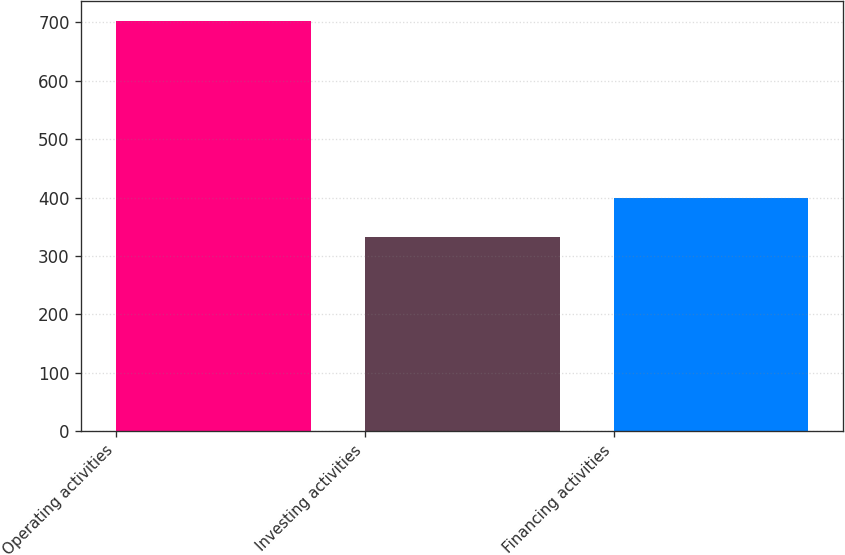Convert chart to OTSL. <chart><loc_0><loc_0><loc_500><loc_500><bar_chart><fcel>Operating activities<fcel>Investing activities<fcel>Financing activities<nl><fcel>702<fcel>333<fcel>400<nl></chart> 